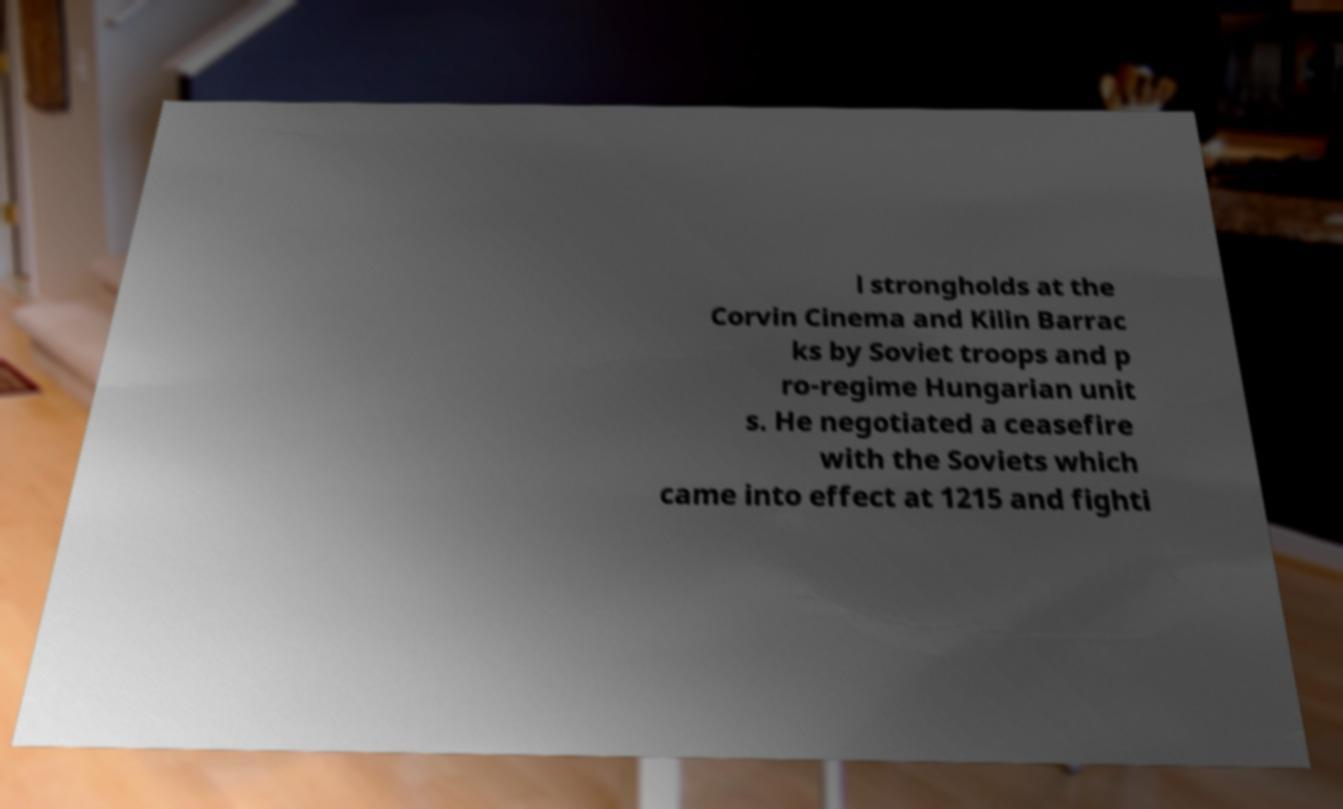For documentation purposes, I need the text within this image transcribed. Could you provide that? l strongholds at the Corvin Cinema and Kilin Barrac ks by Soviet troops and p ro-regime Hungarian unit s. He negotiated a ceasefire with the Soviets which came into effect at 1215 and fighti 